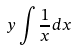Convert formula to latex. <formula><loc_0><loc_0><loc_500><loc_500>y \int \frac { 1 } { x } d x</formula> 